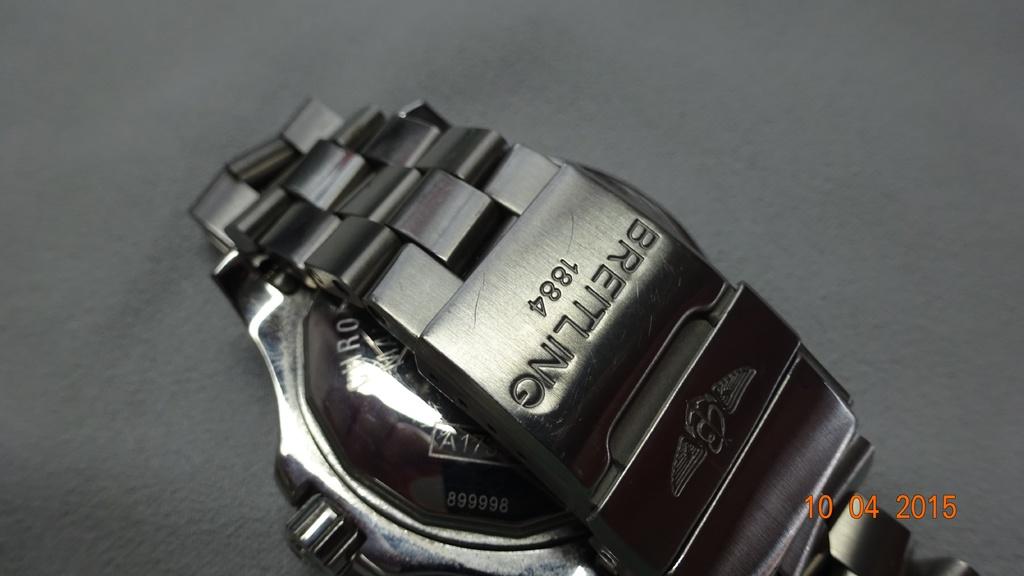What's the year on the watch?
Your response must be concise. 1884. What name is on the watch?
Ensure brevity in your answer.  Breitling. 